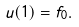<formula> <loc_0><loc_0><loc_500><loc_500>u ( 1 ) = f _ { 0 } .</formula> 